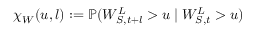<formula> <loc_0><loc_0><loc_500><loc_500>\chi _ { W } ( u , l ) \colon = \mathbb { P } ( W _ { S , t + l } ^ { L } > u | W _ { S , t } ^ { L } > u )</formula> 